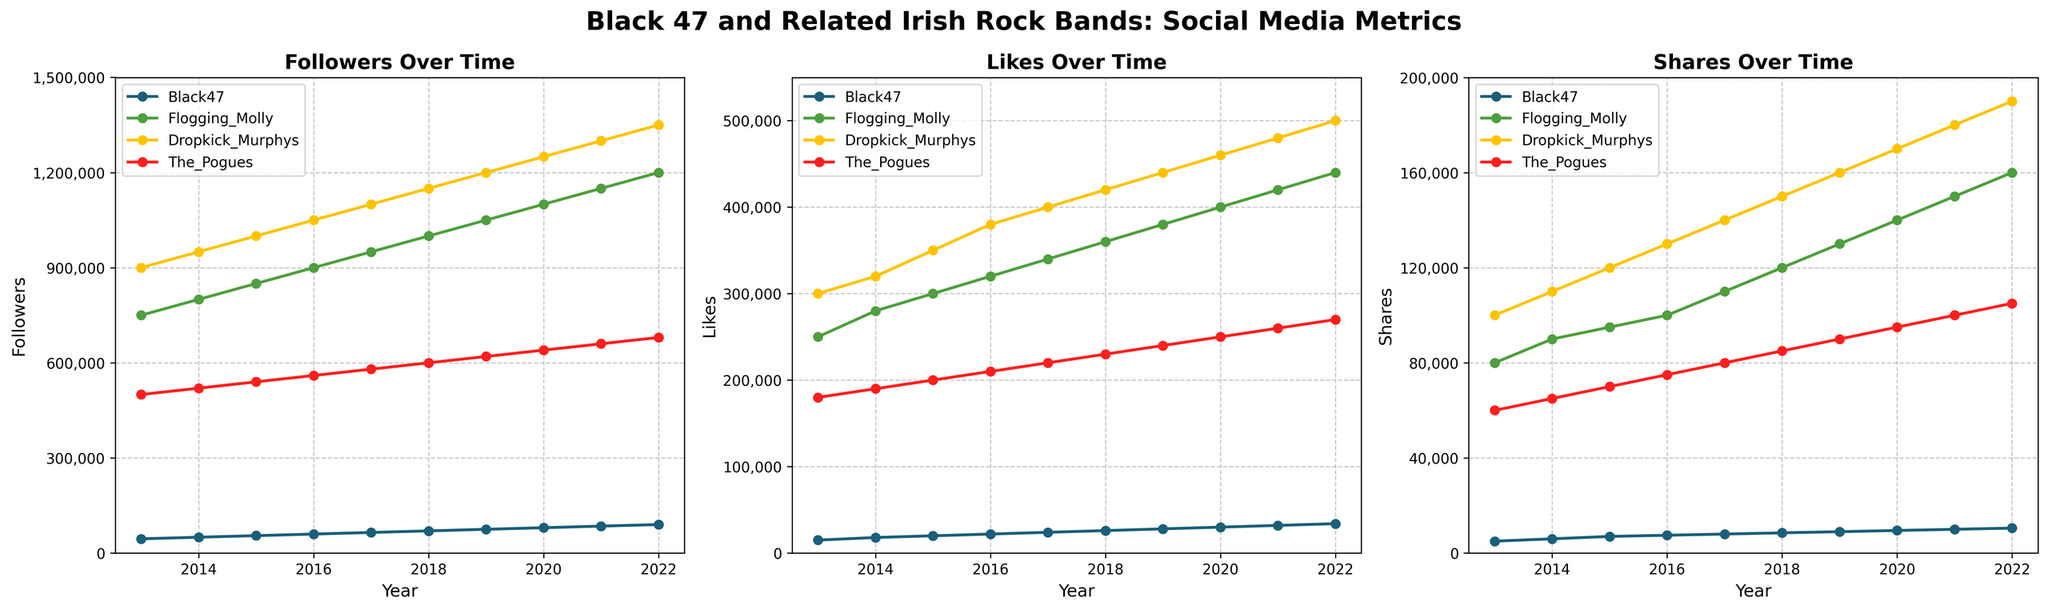What trend can you observe for Black 47's followers over the decade? Looking at the leftmost subplot, Black 47's followers increased steadily from approximately 45,000 in 2013 to 90,000 in 2022.
Answer: Steady increase Which band had the highest number of likes in 2018? Refer to the middle subplot and observe which band had the highest point in 2018. The band with the highest number of likes is Dropkick Murphys with 420,000 likes.
Answer: Dropkick Murphys By how much did Black 47's shares increase from 2014 to 2022? Looking at the rightmost subplot for Black 47, the shares in 2014 are 6,000, and in 2022 they are 10,500. The difference is 10,500 - 6,000 = 4,500.
Answer: 4,500 Which band showed the most significant increase in followers from 2013 to 2022? Examine the leftmost subplot for the steepest growth. Dropkick Murphys' followers increased from 900,000 in 2013 to 1,350,000 in 2022, which is an increase of 450,000—the highest among the bands.
Answer: Dropkick Murphys Which band had consistently fewer shares than the others throughout the decade? In the rightmost subplot, Black 47 consistently has the lowest points for shares from 2013 to 2022 compared to the other bands.
Answer: Black 47 How do the shares of Dropkick Murphys compare to those of The Pogues in 2021? Check the values for both bands in the rightmost subplot for 2021. Dropkick Murphys had 180,000 shares, and The Pogues had 100,000 shares. Thus, Dropkick Murphys had more shares.
Answer: Dropkick Murphys had more shares What is the difference between the number of likes for Black 47 and The Pogues in 2020? Look at the middle subplot for likes in 2020. Black 47 has 30,000 likes, and The Pogues have 250,000 likes. The difference is 250,000 - 30,000 = 220,000.
Answer: 220,000 Did Flogging Molly's followers surpass 1,200,000 by 2022? In the leftmost subplot, Flogging Molly's followers in 2022 are shown to be exactly at 1,200,000, so they did not surpass this number.
Answer: No, it remained at 1,200,000 Which band had the least number of likes in 2013, and what was that number? From the middle subplot in 2013, Black 47 had the least number of likes with 15,000.
Answer: Black 47, 15,000 Among the bands, whose followers grew the least from 2013 to 2022? In the leftmost subplot, Black 47 grew from 45,000 to 90,000, which is a growth of 45,000—the smallest increase compared to the other bands.
Answer: Black 47 